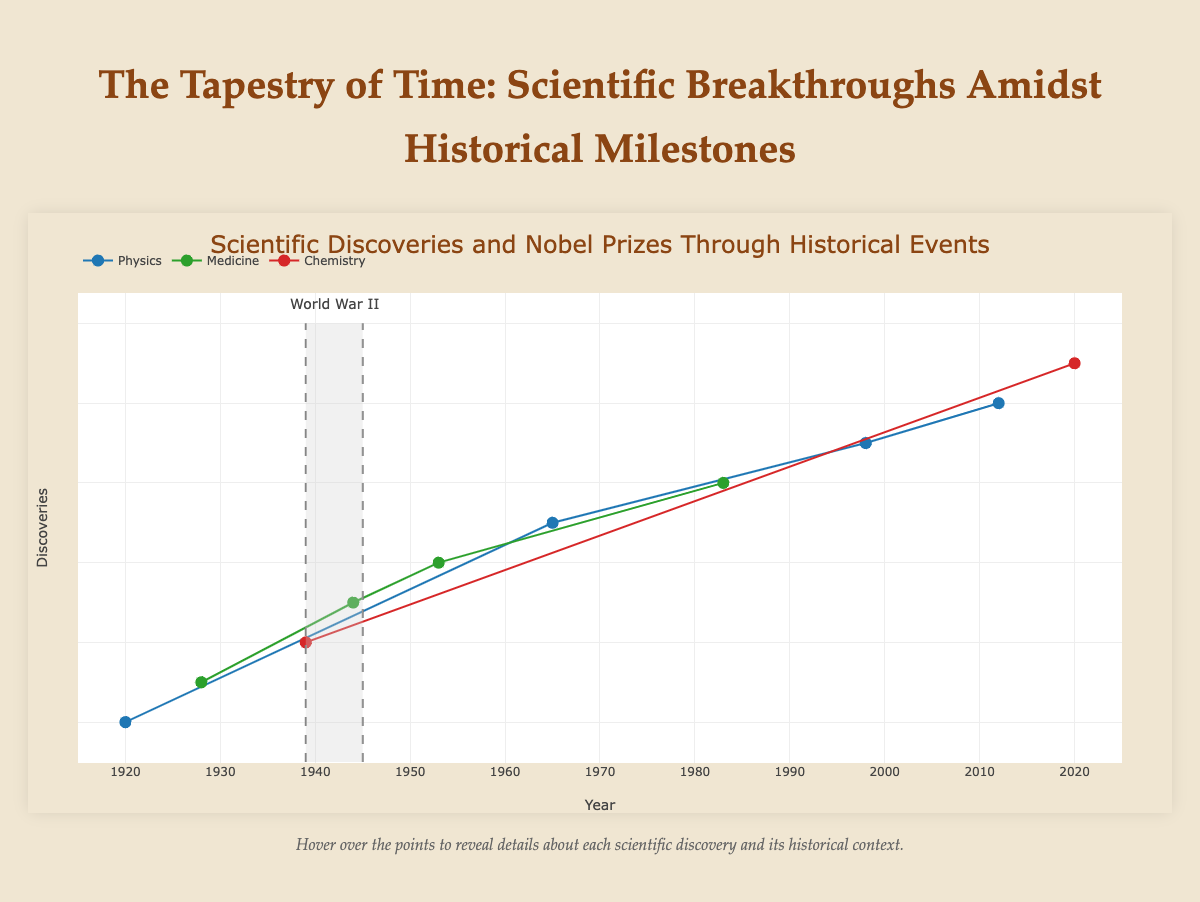What is the title of the plot? The title is prominently placed at the top center of the plot and is easily readable.
Answer: "Scientific Discoveries and Nobel Prizes Through Historical Events" How many discoveries are categorized under Medicine? Medicine is represented by the green color in the plot. By counting the green points, we see there are four discoveries.
Answer: 4 What major historical event coincided with the discovery of the Higgs Boson particle? By hovering over the point for the Higgs Boson particle (year 2012), we find the major event associated with it in the tooltip.
Answer: Post Great Recession Which Nobel Prize category has the most discoveries represented in the plot? By examining the legend and counting the data points for each category, we see that Physics has the most discoveries (blue points).
Answer: Physics What range of years is highlighted as the period of World War II on the plot? The plot has a shaded region and a line annotation indicating the start and end of World War II. The lines are placed at 1939 and 1945, marking this period.
Answer: 1939-1945 Which discovery was made during the COVID-19 Pandemic? By looking at the data points from around 2020 and checking the tooltip for associated historical contexts, we find that CRISPR Gene Editing Technology was discovered during the COVID-19 Pandemic.
Answer: CRISPR Gene Editing Technology Between which two discoveries is there the biggest time gap? The biggest time gap would be the longest horizontal distance between any two points. By comparing the years, we find that the gap between "Cosmic Microwave Background Radiation" (1965) and "HIV as the Cause of AIDS" (1983) is the largest.
Answer: "Cosmic Microwave Background Radiation" and "HIV as the Cause of AIDS" How many Nobel Prizes in Physics were awarded during the Cold War? Cold War discoveries marked by red points should be counted. There are two discoveries categorized as Physics: “Cosmic Microwave Background Radiation” (1965) and “HIV as the Cause of AIDS” (1983).
Answer: 2 Which historical event had multiple discoveries associated with it, based on the data points? By reviewing the major events listed in each tooltip, we find that multiple discoveries were associated with the Cold War and the Post World War II periods. Focusing on the Cold War, we see multiple points.
Answer: Cold War What impact did World War II seem to have on scientific discoveries and Nobel Prize awards? World War II spans a grey-shaded region with fewer discoveries, suggesting a slowdown in scientific breakthroughs. Hovering over 1944 shows the nearby discovery.
Answer: Slowdown during the war, but a major discovery in 1944 